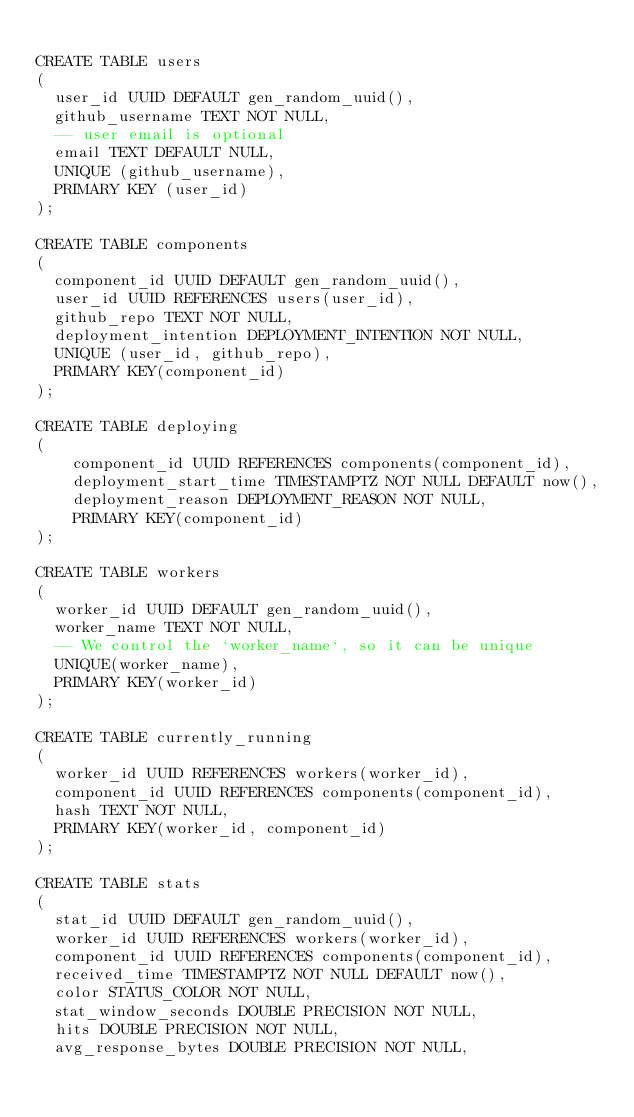Convert code to text. <code><loc_0><loc_0><loc_500><loc_500><_SQL_>
CREATE TABLE users
(
  user_id UUID DEFAULT gen_random_uuid(),
  github_username TEXT NOT NULL,
  -- user email is optional
  email TEXT DEFAULT NULL,
  UNIQUE (github_username),
  PRIMARY KEY (user_id)
);

CREATE TABLE components
(
  component_id UUID DEFAULT gen_random_uuid(),
  user_id UUID REFERENCES users(user_id),
  github_repo TEXT NOT NULL,
  deployment_intention DEPLOYMENT_INTENTION NOT NULL,
  UNIQUE (user_id, github_repo),
  PRIMARY KEY(component_id)
);

CREATE TABLE deploying
(
    component_id UUID REFERENCES components(component_id),
    deployment_start_time TIMESTAMPTZ NOT NULL DEFAULT now(),
    deployment_reason DEPLOYMENT_REASON NOT NULL,
    PRIMARY KEY(component_id)
);

CREATE TABLE workers
(
  worker_id UUID DEFAULT gen_random_uuid(),
  worker_name TEXT NOT NULL,
  -- We control the `worker_name`, so it can be unique
  UNIQUE(worker_name),
  PRIMARY KEY(worker_id)
);

CREATE TABLE currently_running
(
  worker_id UUID REFERENCES workers(worker_id),
  component_id UUID REFERENCES components(component_id),
  hash TEXT NOT NULL,
  PRIMARY KEY(worker_id, component_id)
);

CREATE TABLE stats
(
  stat_id UUID DEFAULT gen_random_uuid(),
  worker_id UUID REFERENCES workers(worker_id),
  component_id UUID REFERENCES components(component_id),
  received_time TIMESTAMPTZ NOT NULL DEFAULT now(),
  color STATUS_COLOR NOT NULL,
  stat_window_seconds DOUBLE PRECISION NOT NULL,
  hits DOUBLE PRECISION NOT NULL,
  avg_response_bytes DOUBLE PRECISION NOT NULL,</code> 